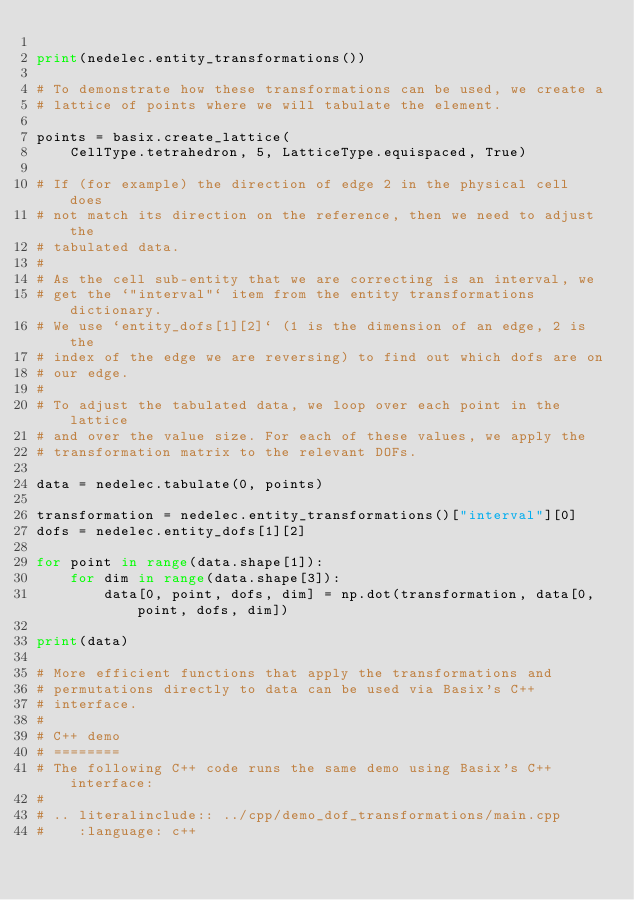Convert code to text. <code><loc_0><loc_0><loc_500><loc_500><_Python_>
print(nedelec.entity_transformations())

# To demonstrate how these transformations can be used, we create a
# lattice of points where we will tabulate the element.

points = basix.create_lattice(
    CellType.tetrahedron, 5, LatticeType.equispaced, True)

# If (for example) the direction of edge 2 in the physical cell does
# not match its direction on the reference, then we need to adjust the
# tabulated data.
#
# As the cell sub-entity that we are correcting is an interval, we
# get the `"interval"` item from the entity transformations dictionary.
# We use `entity_dofs[1][2]` (1 is the dimension of an edge, 2 is the
# index of the edge we are reversing) to find out which dofs are on
# our edge.
#
# To adjust the tabulated data, we loop over each point in the lattice
# and over the value size. For each of these values, we apply the
# transformation matrix to the relevant DOFs.

data = nedelec.tabulate(0, points)

transformation = nedelec.entity_transformations()["interval"][0]
dofs = nedelec.entity_dofs[1][2]

for point in range(data.shape[1]):
    for dim in range(data.shape[3]):
        data[0, point, dofs, dim] = np.dot(transformation, data[0, point, dofs, dim])

print(data)

# More efficient functions that apply the transformations and
# permutations directly to data can be used via Basix's C++
# interface.
#
# C++ demo
# ========
# The following C++ code runs the same demo using Basix's C++ interface:
#
# .. literalinclude:: ../cpp/demo_dof_transformations/main.cpp
#    :language: c++
</code> 